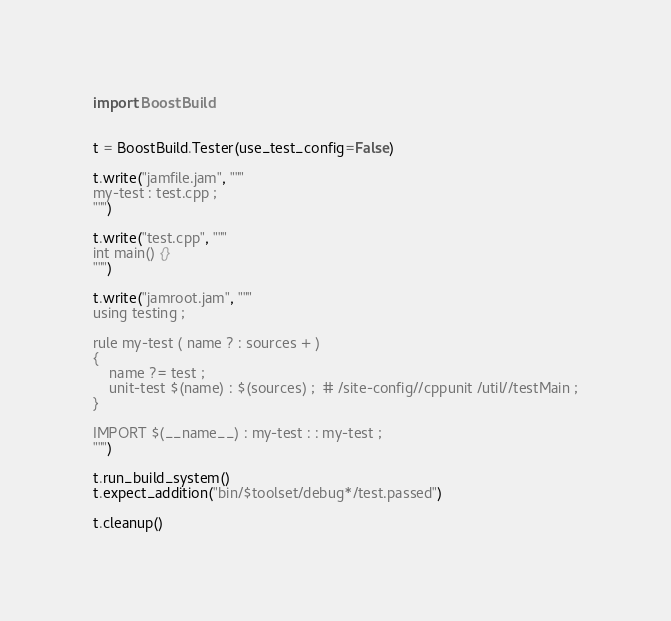Convert code to text. <code><loc_0><loc_0><loc_500><loc_500><_Python_>
import BoostBuild


t = BoostBuild.Tester(use_test_config=False)

t.write("jamfile.jam", """
my-test : test.cpp ;
""")

t.write("test.cpp", """
int main() {}
""")

t.write("jamroot.jam", """
using testing ;

rule my-test ( name ? : sources + )
{
    name ?= test ;
    unit-test $(name) : $(sources) ;  # /site-config//cppunit /util//testMain ;
}

IMPORT $(__name__) : my-test : : my-test ;
""")

t.run_build_system()
t.expect_addition("bin/$toolset/debug*/test.passed")

t.cleanup()
</code> 